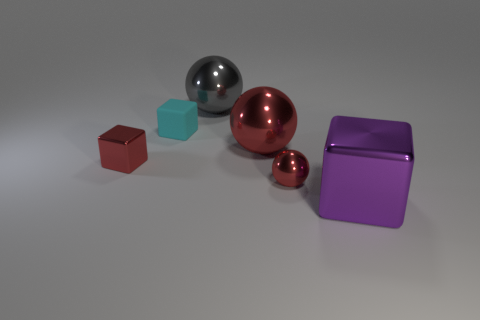There is a small shiny thing that is the same color as the tiny shiny ball; what shape is it?
Provide a succinct answer. Cube. There is a red thing behind the tiny red metal thing left of the large gray metallic sphere; what size is it?
Offer a terse response. Large. How many cylinders are either blue matte objects or large purple metallic things?
Your answer should be very brief. 0. There is a metal sphere that is the same size as the red metallic cube; what color is it?
Make the answer very short. Red. There is a tiny thing behind the metal block to the left of the large cube; what shape is it?
Give a very brief answer. Cube. Do the ball that is behind the cyan rubber thing and the big purple thing have the same size?
Your answer should be very brief. Yes. How many other things are there of the same material as the purple cube?
Your response must be concise. 4. How many purple objects are balls or big shiny things?
Give a very brief answer. 1. The other sphere that is the same color as the small sphere is what size?
Offer a very short reply. Large. How many small objects are behind the small sphere?
Provide a succinct answer. 2. 